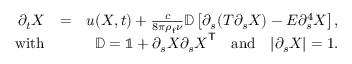Convert formula to latex. <formula><loc_0><loc_0><loc_500><loc_500>\begin{array} { r l r } { \partial _ { t } { X } } & { = } & { { u } ( { X } , t ) + \frac { c } { 8 \pi \rho _ { f } \nu } \mathbb { D } \left [ \partial _ { s } ( T \partial _ { s } { X } ) - E \partial _ { s } ^ { 4 } { X } \right ] , } \\ { w i t h } & { \mathbb { D } = \mathbb { 1 } + \partial _ { s } { X } \partial _ { s } { X } ^ { T } \quad a n d \quad | \partial _ { s } { X } | = 1 . } \end{array}</formula> 